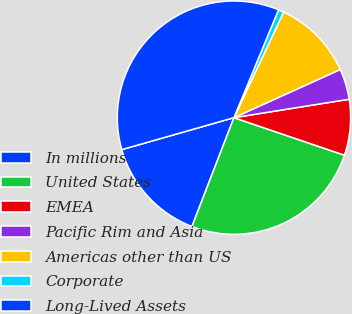<chart> <loc_0><loc_0><loc_500><loc_500><pie_chart><fcel>In millions<fcel>United States<fcel>EMEA<fcel>Pacific Rim and Asia<fcel>Americas other than US<fcel>Corporate<fcel>Long-Lived Assets<nl><fcel>14.72%<fcel>25.65%<fcel>7.74%<fcel>4.25%<fcel>11.23%<fcel>0.76%<fcel>35.66%<nl></chart> 